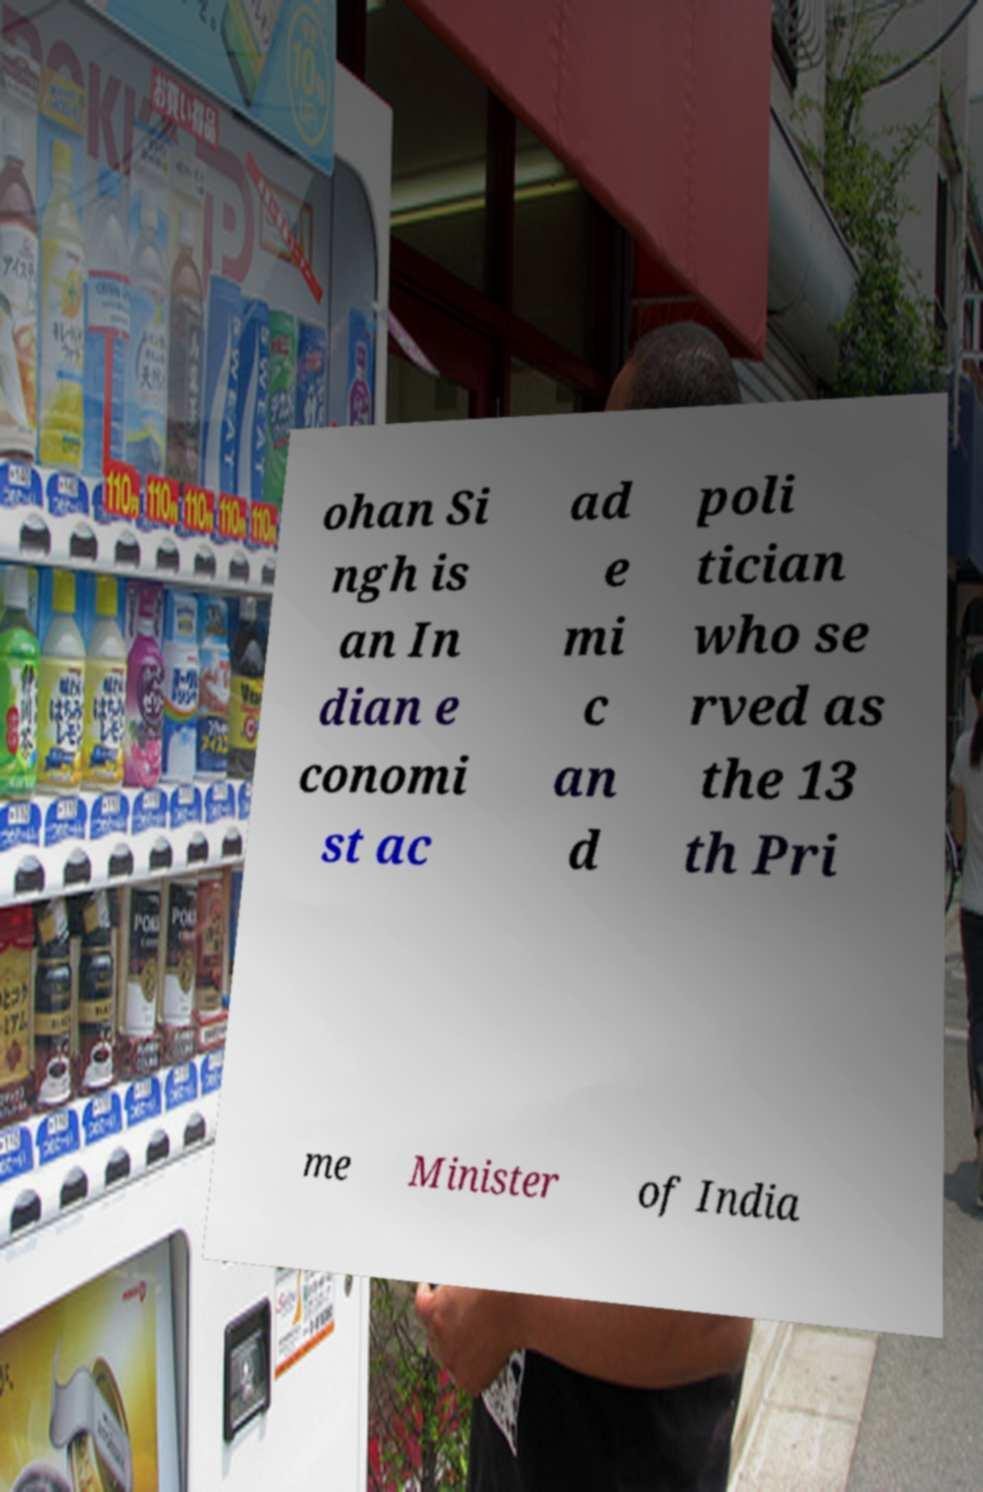What messages or text are displayed in this image? I need them in a readable, typed format. ohan Si ngh is an In dian e conomi st ac ad e mi c an d poli tician who se rved as the 13 th Pri me Minister of India 